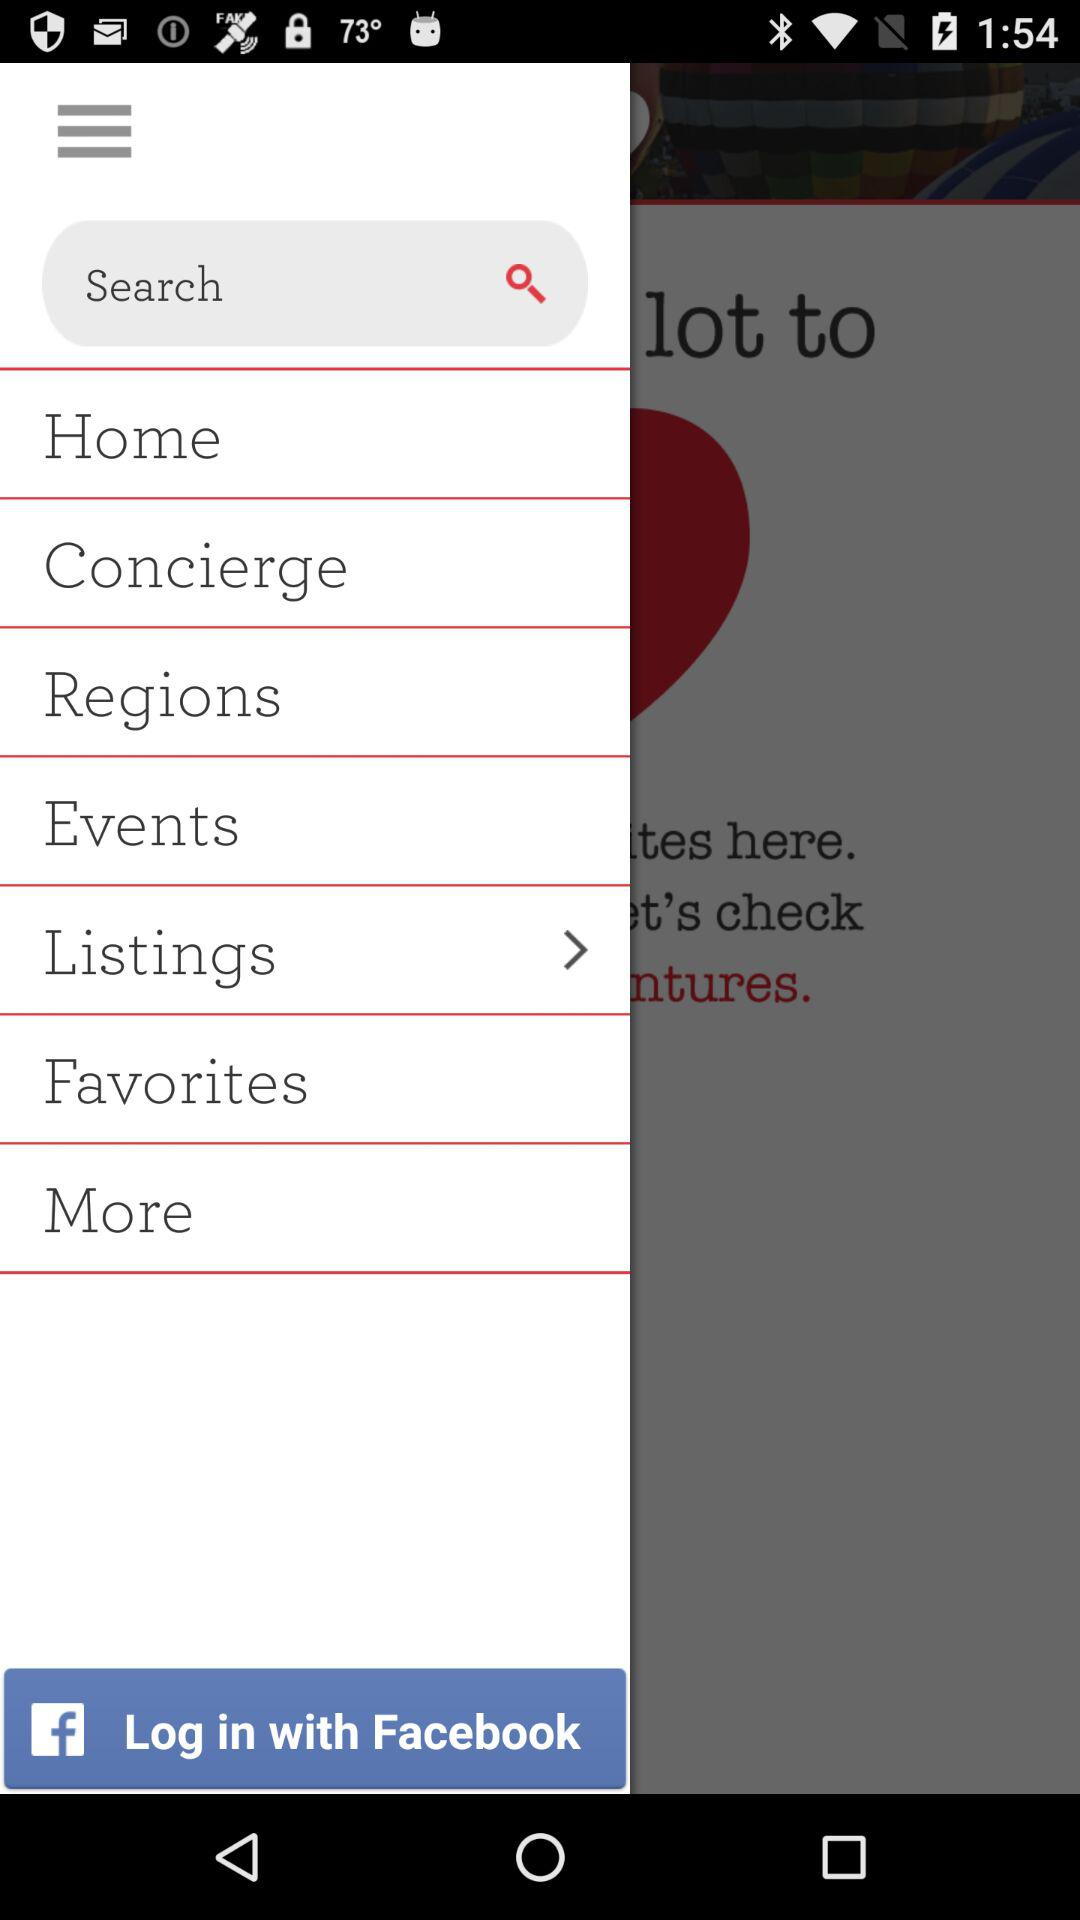What's the selected Menu option?
When the provided information is insufficient, respond with <no answer>. <no answer> 